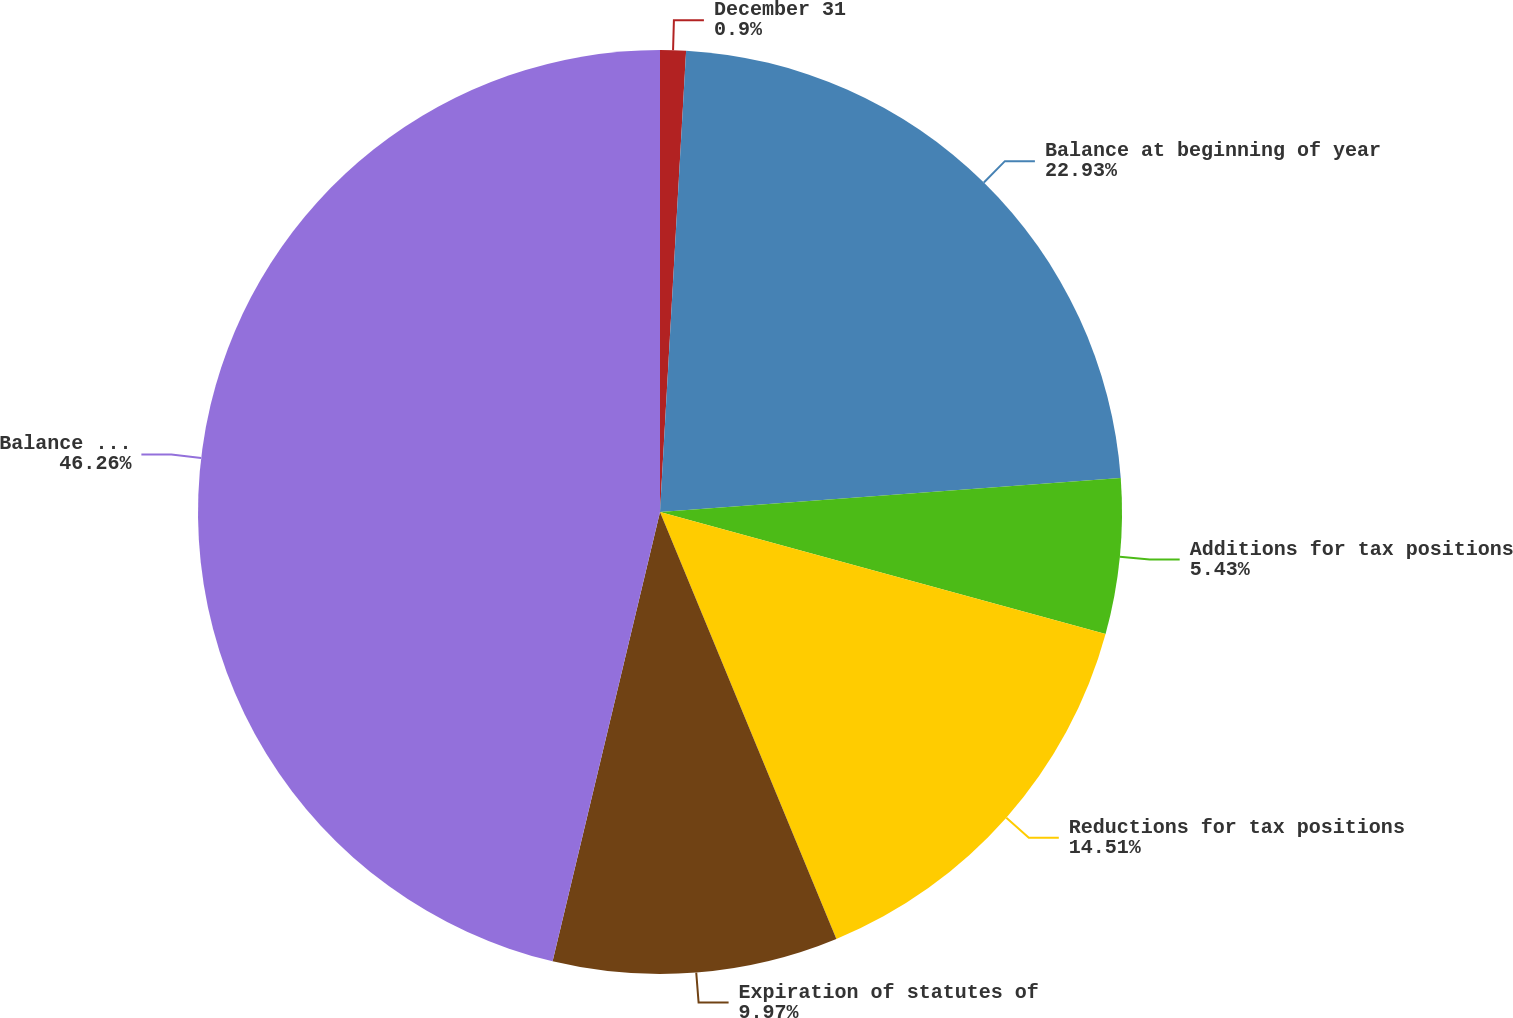Convert chart. <chart><loc_0><loc_0><loc_500><loc_500><pie_chart><fcel>December 31<fcel>Balance at beginning of year<fcel>Additions for tax positions<fcel>Reductions for tax positions<fcel>Expiration of statutes of<fcel>Balance at end of year<nl><fcel>0.9%<fcel>22.93%<fcel>5.43%<fcel>14.51%<fcel>9.97%<fcel>46.27%<nl></chart> 